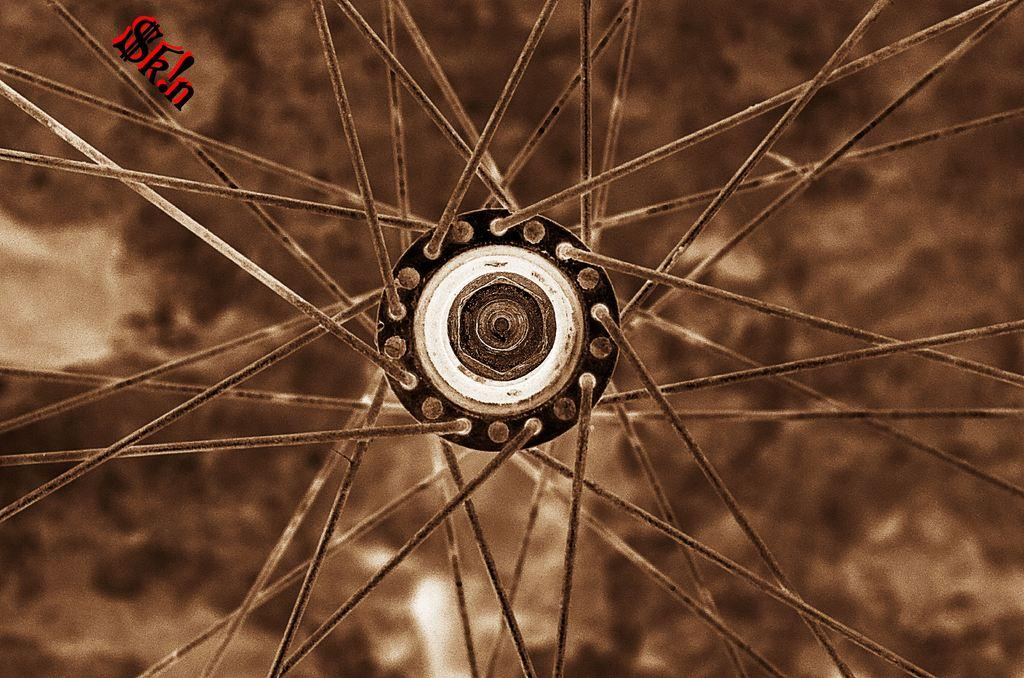Where was the image taken? The image was taken outdoors. Can you describe the background of the image? The background of the image is slightly blurred. What is the main subject of the image? There is a wheel of a bicycle in the middle of the image. What type of rod is being used to stir the water in the basin in the image? There is no rod or basin present in the image. 